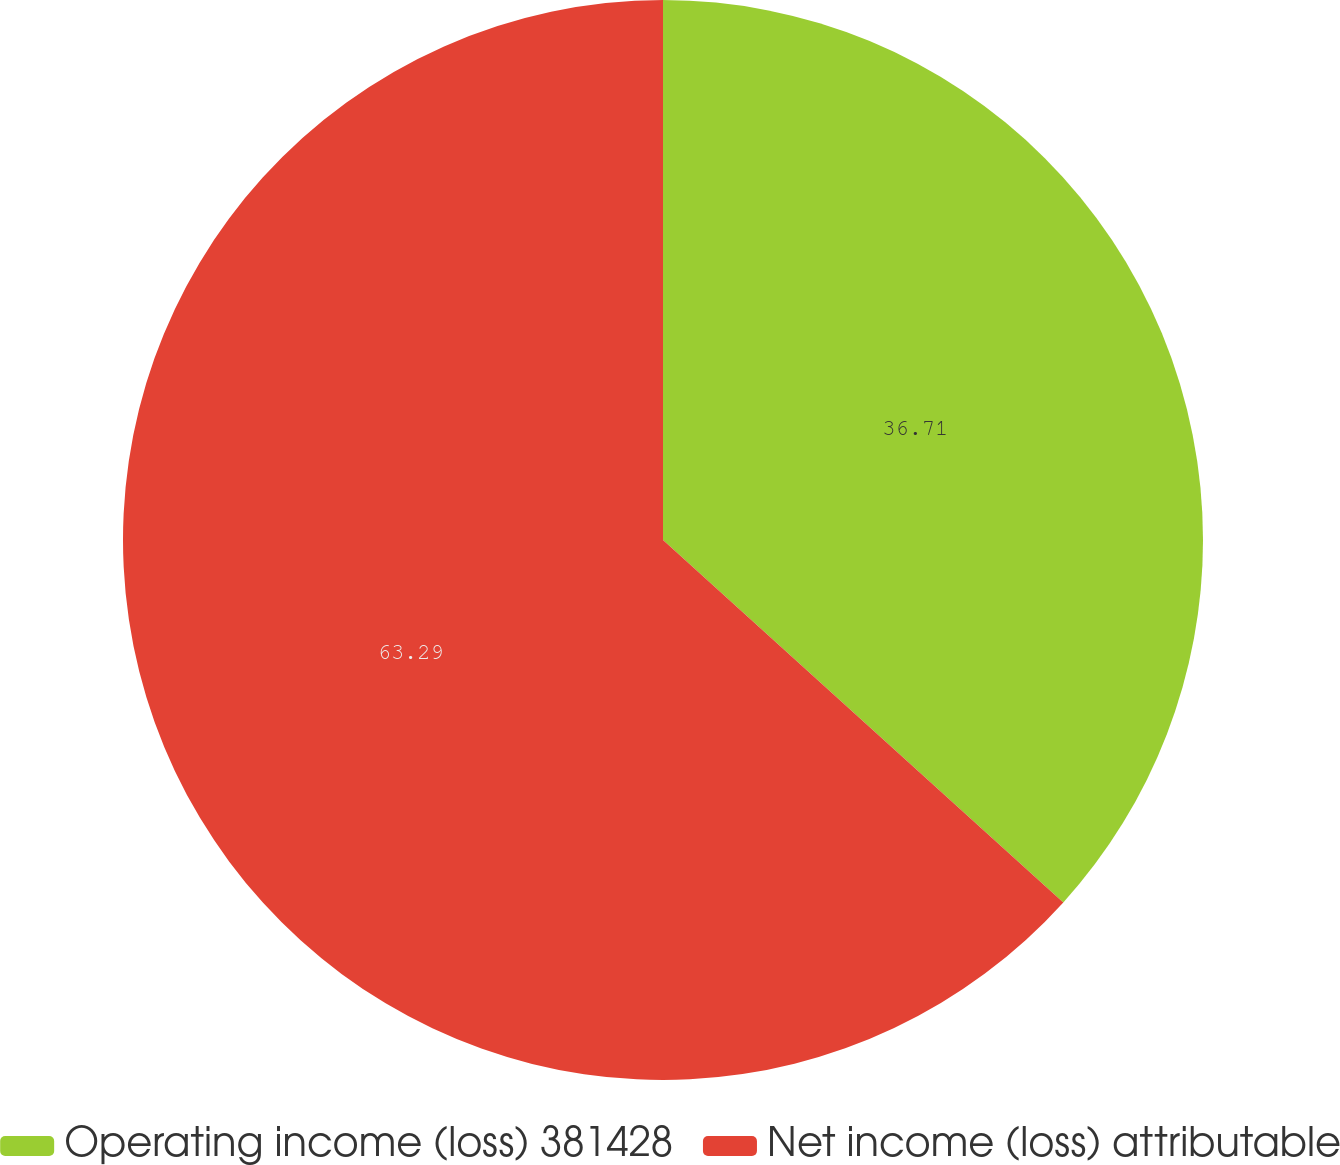Convert chart. <chart><loc_0><loc_0><loc_500><loc_500><pie_chart><fcel>Operating income (loss) 381428<fcel>Net income (loss) attributable<nl><fcel>36.71%<fcel>63.29%<nl></chart> 